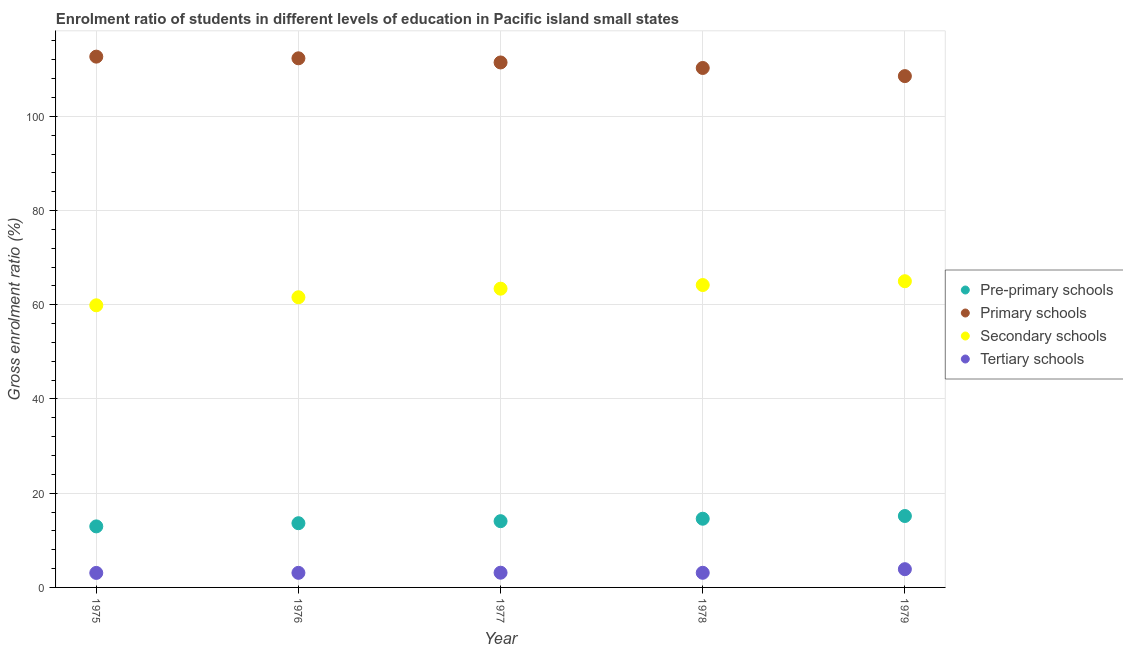How many different coloured dotlines are there?
Keep it short and to the point. 4. Is the number of dotlines equal to the number of legend labels?
Your response must be concise. Yes. What is the gross enrolment ratio in tertiary schools in 1976?
Give a very brief answer. 3.1. Across all years, what is the maximum gross enrolment ratio in primary schools?
Keep it short and to the point. 112.67. Across all years, what is the minimum gross enrolment ratio in tertiary schools?
Keep it short and to the point. 3.08. In which year was the gross enrolment ratio in tertiary schools maximum?
Make the answer very short. 1979. In which year was the gross enrolment ratio in pre-primary schools minimum?
Provide a short and direct response. 1975. What is the total gross enrolment ratio in pre-primary schools in the graph?
Offer a terse response. 70.39. What is the difference between the gross enrolment ratio in secondary schools in 1975 and that in 1977?
Give a very brief answer. -3.53. What is the difference between the gross enrolment ratio in primary schools in 1978 and the gross enrolment ratio in pre-primary schools in 1977?
Provide a short and direct response. 96.2. What is the average gross enrolment ratio in primary schools per year?
Your answer should be very brief. 111.04. In the year 1977, what is the difference between the gross enrolment ratio in primary schools and gross enrolment ratio in secondary schools?
Make the answer very short. 48.02. What is the ratio of the gross enrolment ratio in pre-primary schools in 1977 to that in 1978?
Offer a terse response. 0.96. Is the gross enrolment ratio in secondary schools in 1976 less than that in 1978?
Your response must be concise. Yes. What is the difference between the highest and the second highest gross enrolment ratio in primary schools?
Provide a succinct answer. 0.35. What is the difference between the highest and the lowest gross enrolment ratio in tertiary schools?
Provide a succinct answer. 0.79. Is the sum of the gross enrolment ratio in secondary schools in 1976 and 1979 greater than the maximum gross enrolment ratio in pre-primary schools across all years?
Provide a short and direct response. Yes. Is it the case that in every year, the sum of the gross enrolment ratio in primary schools and gross enrolment ratio in tertiary schools is greater than the sum of gross enrolment ratio in pre-primary schools and gross enrolment ratio in secondary schools?
Give a very brief answer. Yes. Is it the case that in every year, the sum of the gross enrolment ratio in pre-primary schools and gross enrolment ratio in primary schools is greater than the gross enrolment ratio in secondary schools?
Offer a very short reply. Yes. Does the gross enrolment ratio in secondary schools monotonically increase over the years?
Make the answer very short. Yes. Is the gross enrolment ratio in tertiary schools strictly greater than the gross enrolment ratio in primary schools over the years?
Ensure brevity in your answer.  No. Is the gross enrolment ratio in primary schools strictly less than the gross enrolment ratio in pre-primary schools over the years?
Make the answer very short. No. Does the graph contain any zero values?
Provide a short and direct response. No. Does the graph contain grids?
Offer a very short reply. Yes. How are the legend labels stacked?
Keep it short and to the point. Vertical. What is the title of the graph?
Your answer should be compact. Enrolment ratio of students in different levels of education in Pacific island small states. Does "Agricultural land" appear as one of the legend labels in the graph?
Provide a succinct answer. No. What is the label or title of the X-axis?
Your response must be concise. Year. What is the Gross enrolment ratio (%) of Pre-primary schools in 1975?
Keep it short and to the point. 12.96. What is the Gross enrolment ratio (%) of Primary schools in 1975?
Ensure brevity in your answer.  112.67. What is the Gross enrolment ratio (%) of Secondary schools in 1975?
Give a very brief answer. 59.89. What is the Gross enrolment ratio (%) in Tertiary schools in 1975?
Ensure brevity in your answer.  3.08. What is the Gross enrolment ratio (%) of Pre-primary schools in 1976?
Your answer should be very brief. 13.63. What is the Gross enrolment ratio (%) of Primary schools in 1976?
Your answer should be very brief. 112.32. What is the Gross enrolment ratio (%) of Secondary schools in 1976?
Ensure brevity in your answer.  61.59. What is the Gross enrolment ratio (%) in Tertiary schools in 1976?
Ensure brevity in your answer.  3.1. What is the Gross enrolment ratio (%) of Pre-primary schools in 1977?
Your answer should be compact. 14.06. What is the Gross enrolment ratio (%) of Primary schools in 1977?
Your answer should be compact. 111.43. What is the Gross enrolment ratio (%) in Secondary schools in 1977?
Make the answer very short. 63.42. What is the Gross enrolment ratio (%) in Tertiary schools in 1977?
Make the answer very short. 3.12. What is the Gross enrolment ratio (%) of Pre-primary schools in 1978?
Ensure brevity in your answer.  14.58. What is the Gross enrolment ratio (%) in Primary schools in 1978?
Offer a very short reply. 110.27. What is the Gross enrolment ratio (%) of Secondary schools in 1978?
Offer a terse response. 64.19. What is the Gross enrolment ratio (%) in Tertiary schools in 1978?
Offer a terse response. 3.11. What is the Gross enrolment ratio (%) of Pre-primary schools in 1979?
Offer a terse response. 15.16. What is the Gross enrolment ratio (%) of Primary schools in 1979?
Offer a terse response. 108.54. What is the Gross enrolment ratio (%) of Secondary schools in 1979?
Your answer should be very brief. 65. What is the Gross enrolment ratio (%) of Tertiary schools in 1979?
Keep it short and to the point. 3.87. Across all years, what is the maximum Gross enrolment ratio (%) in Pre-primary schools?
Keep it short and to the point. 15.16. Across all years, what is the maximum Gross enrolment ratio (%) in Primary schools?
Give a very brief answer. 112.67. Across all years, what is the maximum Gross enrolment ratio (%) in Secondary schools?
Make the answer very short. 65. Across all years, what is the maximum Gross enrolment ratio (%) in Tertiary schools?
Your response must be concise. 3.87. Across all years, what is the minimum Gross enrolment ratio (%) of Pre-primary schools?
Your response must be concise. 12.96. Across all years, what is the minimum Gross enrolment ratio (%) in Primary schools?
Ensure brevity in your answer.  108.54. Across all years, what is the minimum Gross enrolment ratio (%) of Secondary schools?
Provide a short and direct response. 59.89. Across all years, what is the minimum Gross enrolment ratio (%) of Tertiary schools?
Your response must be concise. 3.08. What is the total Gross enrolment ratio (%) in Pre-primary schools in the graph?
Provide a short and direct response. 70.39. What is the total Gross enrolment ratio (%) in Primary schools in the graph?
Ensure brevity in your answer.  555.22. What is the total Gross enrolment ratio (%) in Secondary schools in the graph?
Make the answer very short. 314.09. What is the total Gross enrolment ratio (%) in Tertiary schools in the graph?
Make the answer very short. 16.28. What is the difference between the Gross enrolment ratio (%) of Pre-primary schools in 1975 and that in 1976?
Keep it short and to the point. -0.68. What is the difference between the Gross enrolment ratio (%) in Primary schools in 1975 and that in 1976?
Keep it short and to the point. 0.35. What is the difference between the Gross enrolment ratio (%) in Secondary schools in 1975 and that in 1976?
Give a very brief answer. -1.71. What is the difference between the Gross enrolment ratio (%) in Tertiary schools in 1975 and that in 1976?
Provide a succinct answer. -0.01. What is the difference between the Gross enrolment ratio (%) in Pre-primary schools in 1975 and that in 1977?
Ensure brevity in your answer.  -1.11. What is the difference between the Gross enrolment ratio (%) in Primary schools in 1975 and that in 1977?
Offer a terse response. 1.24. What is the difference between the Gross enrolment ratio (%) in Secondary schools in 1975 and that in 1977?
Keep it short and to the point. -3.53. What is the difference between the Gross enrolment ratio (%) of Tertiary schools in 1975 and that in 1977?
Provide a succinct answer. -0.04. What is the difference between the Gross enrolment ratio (%) of Pre-primary schools in 1975 and that in 1978?
Offer a very short reply. -1.63. What is the difference between the Gross enrolment ratio (%) of Primary schools in 1975 and that in 1978?
Provide a short and direct response. 2.41. What is the difference between the Gross enrolment ratio (%) in Secondary schools in 1975 and that in 1978?
Provide a short and direct response. -4.3. What is the difference between the Gross enrolment ratio (%) of Tertiary schools in 1975 and that in 1978?
Your answer should be very brief. -0.03. What is the difference between the Gross enrolment ratio (%) in Pre-primary schools in 1975 and that in 1979?
Provide a short and direct response. -2.21. What is the difference between the Gross enrolment ratio (%) of Primary schools in 1975 and that in 1979?
Ensure brevity in your answer.  4.13. What is the difference between the Gross enrolment ratio (%) of Secondary schools in 1975 and that in 1979?
Keep it short and to the point. -5.11. What is the difference between the Gross enrolment ratio (%) of Tertiary schools in 1975 and that in 1979?
Ensure brevity in your answer.  -0.79. What is the difference between the Gross enrolment ratio (%) of Pre-primary schools in 1976 and that in 1977?
Offer a terse response. -0.43. What is the difference between the Gross enrolment ratio (%) in Primary schools in 1976 and that in 1977?
Make the answer very short. 0.88. What is the difference between the Gross enrolment ratio (%) in Secondary schools in 1976 and that in 1977?
Keep it short and to the point. -1.82. What is the difference between the Gross enrolment ratio (%) in Tertiary schools in 1976 and that in 1977?
Your answer should be compact. -0.03. What is the difference between the Gross enrolment ratio (%) of Pre-primary schools in 1976 and that in 1978?
Make the answer very short. -0.95. What is the difference between the Gross enrolment ratio (%) in Primary schools in 1976 and that in 1978?
Keep it short and to the point. 2.05. What is the difference between the Gross enrolment ratio (%) in Secondary schools in 1976 and that in 1978?
Keep it short and to the point. -2.6. What is the difference between the Gross enrolment ratio (%) in Tertiary schools in 1976 and that in 1978?
Make the answer very short. -0.01. What is the difference between the Gross enrolment ratio (%) of Pre-primary schools in 1976 and that in 1979?
Ensure brevity in your answer.  -1.53. What is the difference between the Gross enrolment ratio (%) in Primary schools in 1976 and that in 1979?
Offer a very short reply. 3.78. What is the difference between the Gross enrolment ratio (%) in Secondary schools in 1976 and that in 1979?
Offer a very short reply. -3.41. What is the difference between the Gross enrolment ratio (%) in Tertiary schools in 1976 and that in 1979?
Offer a terse response. -0.78. What is the difference between the Gross enrolment ratio (%) of Pre-primary schools in 1977 and that in 1978?
Your response must be concise. -0.52. What is the difference between the Gross enrolment ratio (%) in Primary schools in 1977 and that in 1978?
Your answer should be compact. 1.17. What is the difference between the Gross enrolment ratio (%) in Secondary schools in 1977 and that in 1978?
Give a very brief answer. -0.77. What is the difference between the Gross enrolment ratio (%) in Tertiary schools in 1977 and that in 1978?
Your response must be concise. 0.02. What is the difference between the Gross enrolment ratio (%) in Pre-primary schools in 1977 and that in 1979?
Provide a succinct answer. -1.1. What is the difference between the Gross enrolment ratio (%) of Primary schools in 1977 and that in 1979?
Your answer should be compact. 2.9. What is the difference between the Gross enrolment ratio (%) of Secondary schools in 1977 and that in 1979?
Offer a very short reply. -1.58. What is the difference between the Gross enrolment ratio (%) in Tertiary schools in 1977 and that in 1979?
Offer a very short reply. -0.75. What is the difference between the Gross enrolment ratio (%) of Pre-primary schools in 1978 and that in 1979?
Your answer should be very brief. -0.58. What is the difference between the Gross enrolment ratio (%) in Primary schools in 1978 and that in 1979?
Provide a short and direct response. 1.73. What is the difference between the Gross enrolment ratio (%) of Secondary schools in 1978 and that in 1979?
Keep it short and to the point. -0.81. What is the difference between the Gross enrolment ratio (%) in Tertiary schools in 1978 and that in 1979?
Make the answer very short. -0.76. What is the difference between the Gross enrolment ratio (%) of Pre-primary schools in 1975 and the Gross enrolment ratio (%) of Primary schools in 1976?
Make the answer very short. -99.36. What is the difference between the Gross enrolment ratio (%) of Pre-primary schools in 1975 and the Gross enrolment ratio (%) of Secondary schools in 1976?
Your response must be concise. -48.64. What is the difference between the Gross enrolment ratio (%) in Pre-primary schools in 1975 and the Gross enrolment ratio (%) in Tertiary schools in 1976?
Offer a terse response. 9.86. What is the difference between the Gross enrolment ratio (%) in Primary schools in 1975 and the Gross enrolment ratio (%) in Secondary schools in 1976?
Offer a very short reply. 51.08. What is the difference between the Gross enrolment ratio (%) in Primary schools in 1975 and the Gross enrolment ratio (%) in Tertiary schools in 1976?
Your response must be concise. 109.58. What is the difference between the Gross enrolment ratio (%) of Secondary schools in 1975 and the Gross enrolment ratio (%) of Tertiary schools in 1976?
Your answer should be very brief. 56.79. What is the difference between the Gross enrolment ratio (%) of Pre-primary schools in 1975 and the Gross enrolment ratio (%) of Primary schools in 1977?
Your answer should be compact. -98.48. What is the difference between the Gross enrolment ratio (%) in Pre-primary schools in 1975 and the Gross enrolment ratio (%) in Secondary schools in 1977?
Give a very brief answer. -50.46. What is the difference between the Gross enrolment ratio (%) of Pre-primary schools in 1975 and the Gross enrolment ratio (%) of Tertiary schools in 1977?
Your answer should be very brief. 9.83. What is the difference between the Gross enrolment ratio (%) in Primary schools in 1975 and the Gross enrolment ratio (%) in Secondary schools in 1977?
Your response must be concise. 49.26. What is the difference between the Gross enrolment ratio (%) in Primary schools in 1975 and the Gross enrolment ratio (%) in Tertiary schools in 1977?
Make the answer very short. 109.55. What is the difference between the Gross enrolment ratio (%) in Secondary schools in 1975 and the Gross enrolment ratio (%) in Tertiary schools in 1977?
Provide a succinct answer. 56.76. What is the difference between the Gross enrolment ratio (%) of Pre-primary schools in 1975 and the Gross enrolment ratio (%) of Primary schools in 1978?
Make the answer very short. -97.31. What is the difference between the Gross enrolment ratio (%) of Pre-primary schools in 1975 and the Gross enrolment ratio (%) of Secondary schools in 1978?
Offer a very short reply. -51.23. What is the difference between the Gross enrolment ratio (%) in Pre-primary schools in 1975 and the Gross enrolment ratio (%) in Tertiary schools in 1978?
Provide a succinct answer. 9.85. What is the difference between the Gross enrolment ratio (%) of Primary schools in 1975 and the Gross enrolment ratio (%) of Secondary schools in 1978?
Offer a terse response. 48.48. What is the difference between the Gross enrolment ratio (%) in Primary schools in 1975 and the Gross enrolment ratio (%) in Tertiary schools in 1978?
Make the answer very short. 109.56. What is the difference between the Gross enrolment ratio (%) of Secondary schools in 1975 and the Gross enrolment ratio (%) of Tertiary schools in 1978?
Keep it short and to the point. 56.78. What is the difference between the Gross enrolment ratio (%) in Pre-primary schools in 1975 and the Gross enrolment ratio (%) in Primary schools in 1979?
Provide a short and direct response. -95.58. What is the difference between the Gross enrolment ratio (%) of Pre-primary schools in 1975 and the Gross enrolment ratio (%) of Secondary schools in 1979?
Make the answer very short. -52.04. What is the difference between the Gross enrolment ratio (%) in Pre-primary schools in 1975 and the Gross enrolment ratio (%) in Tertiary schools in 1979?
Offer a very short reply. 9.08. What is the difference between the Gross enrolment ratio (%) in Primary schools in 1975 and the Gross enrolment ratio (%) in Secondary schools in 1979?
Keep it short and to the point. 47.67. What is the difference between the Gross enrolment ratio (%) in Primary schools in 1975 and the Gross enrolment ratio (%) in Tertiary schools in 1979?
Your answer should be very brief. 108.8. What is the difference between the Gross enrolment ratio (%) of Secondary schools in 1975 and the Gross enrolment ratio (%) of Tertiary schools in 1979?
Keep it short and to the point. 56.02. What is the difference between the Gross enrolment ratio (%) in Pre-primary schools in 1976 and the Gross enrolment ratio (%) in Primary schools in 1977?
Provide a succinct answer. -97.8. What is the difference between the Gross enrolment ratio (%) of Pre-primary schools in 1976 and the Gross enrolment ratio (%) of Secondary schools in 1977?
Ensure brevity in your answer.  -49.78. What is the difference between the Gross enrolment ratio (%) in Pre-primary schools in 1976 and the Gross enrolment ratio (%) in Tertiary schools in 1977?
Your response must be concise. 10.51. What is the difference between the Gross enrolment ratio (%) of Primary schools in 1976 and the Gross enrolment ratio (%) of Secondary schools in 1977?
Give a very brief answer. 48.9. What is the difference between the Gross enrolment ratio (%) in Primary schools in 1976 and the Gross enrolment ratio (%) in Tertiary schools in 1977?
Offer a terse response. 109.19. What is the difference between the Gross enrolment ratio (%) of Secondary schools in 1976 and the Gross enrolment ratio (%) of Tertiary schools in 1977?
Make the answer very short. 58.47. What is the difference between the Gross enrolment ratio (%) in Pre-primary schools in 1976 and the Gross enrolment ratio (%) in Primary schools in 1978?
Offer a very short reply. -96.63. What is the difference between the Gross enrolment ratio (%) in Pre-primary schools in 1976 and the Gross enrolment ratio (%) in Secondary schools in 1978?
Provide a succinct answer. -50.56. What is the difference between the Gross enrolment ratio (%) of Pre-primary schools in 1976 and the Gross enrolment ratio (%) of Tertiary schools in 1978?
Your answer should be compact. 10.52. What is the difference between the Gross enrolment ratio (%) of Primary schools in 1976 and the Gross enrolment ratio (%) of Secondary schools in 1978?
Give a very brief answer. 48.13. What is the difference between the Gross enrolment ratio (%) of Primary schools in 1976 and the Gross enrolment ratio (%) of Tertiary schools in 1978?
Give a very brief answer. 109.21. What is the difference between the Gross enrolment ratio (%) in Secondary schools in 1976 and the Gross enrolment ratio (%) in Tertiary schools in 1978?
Provide a short and direct response. 58.49. What is the difference between the Gross enrolment ratio (%) in Pre-primary schools in 1976 and the Gross enrolment ratio (%) in Primary schools in 1979?
Your answer should be compact. -94.91. What is the difference between the Gross enrolment ratio (%) in Pre-primary schools in 1976 and the Gross enrolment ratio (%) in Secondary schools in 1979?
Offer a very short reply. -51.37. What is the difference between the Gross enrolment ratio (%) of Pre-primary schools in 1976 and the Gross enrolment ratio (%) of Tertiary schools in 1979?
Provide a succinct answer. 9.76. What is the difference between the Gross enrolment ratio (%) of Primary schools in 1976 and the Gross enrolment ratio (%) of Secondary schools in 1979?
Provide a short and direct response. 47.32. What is the difference between the Gross enrolment ratio (%) in Primary schools in 1976 and the Gross enrolment ratio (%) in Tertiary schools in 1979?
Your response must be concise. 108.44. What is the difference between the Gross enrolment ratio (%) in Secondary schools in 1976 and the Gross enrolment ratio (%) in Tertiary schools in 1979?
Give a very brief answer. 57.72. What is the difference between the Gross enrolment ratio (%) in Pre-primary schools in 1977 and the Gross enrolment ratio (%) in Primary schools in 1978?
Give a very brief answer. -96.2. What is the difference between the Gross enrolment ratio (%) in Pre-primary schools in 1977 and the Gross enrolment ratio (%) in Secondary schools in 1978?
Ensure brevity in your answer.  -50.13. What is the difference between the Gross enrolment ratio (%) in Pre-primary schools in 1977 and the Gross enrolment ratio (%) in Tertiary schools in 1978?
Give a very brief answer. 10.96. What is the difference between the Gross enrolment ratio (%) in Primary schools in 1977 and the Gross enrolment ratio (%) in Secondary schools in 1978?
Give a very brief answer. 47.25. What is the difference between the Gross enrolment ratio (%) of Primary schools in 1977 and the Gross enrolment ratio (%) of Tertiary schools in 1978?
Offer a very short reply. 108.33. What is the difference between the Gross enrolment ratio (%) of Secondary schools in 1977 and the Gross enrolment ratio (%) of Tertiary schools in 1978?
Your response must be concise. 60.31. What is the difference between the Gross enrolment ratio (%) of Pre-primary schools in 1977 and the Gross enrolment ratio (%) of Primary schools in 1979?
Offer a very short reply. -94.47. What is the difference between the Gross enrolment ratio (%) of Pre-primary schools in 1977 and the Gross enrolment ratio (%) of Secondary schools in 1979?
Ensure brevity in your answer.  -50.94. What is the difference between the Gross enrolment ratio (%) of Pre-primary schools in 1977 and the Gross enrolment ratio (%) of Tertiary schools in 1979?
Ensure brevity in your answer.  10.19. What is the difference between the Gross enrolment ratio (%) in Primary schools in 1977 and the Gross enrolment ratio (%) in Secondary schools in 1979?
Provide a succinct answer. 46.44. What is the difference between the Gross enrolment ratio (%) in Primary schools in 1977 and the Gross enrolment ratio (%) in Tertiary schools in 1979?
Offer a very short reply. 107.56. What is the difference between the Gross enrolment ratio (%) in Secondary schools in 1977 and the Gross enrolment ratio (%) in Tertiary schools in 1979?
Your answer should be very brief. 59.54. What is the difference between the Gross enrolment ratio (%) of Pre-primary schools in 1978 and the Gross enrolment ratio (%) of Primary schools in 1979?
Provide a succinct answer. -93.95. What is the difference between the Gross enrolment ratio (%) of Pre-primary schools in 1978 and the Gross enrolment ratio (%) of Secondary schools in 1979?
Give a very brief answer. -50.42. What is the difference between the Gross enrolment ratio (%) of Pre-primary schools in 1978 and the Gross enrolment ratio (%) of Tertiary schools in 1979?
Ensure brevity in your answer.  10.71. What is the difference between the Gross enrolment ratio (%) of Primary schools in 1978 and the Gross enrolment ratio (%) of Secondary schools in 1979?
Keep it short and to the point. 45.27. What is the difference between the Gross enrolment ratio (%) in Primary schools in 1978 and the Gross enrolment ratio (%) in Tertiary schools in 1979?
Provide a short and direct response. 106.39. What is the difference between the Gross enrolment ratio (%) of Secondary schools in 1978 and the Gross enrolment ratio (%) of Tertiary schools in 1979?
Ensure brevity in your answer.  60.32. What is the average Gross enrolment ratio (%) in Pre-primary schools per year?
Ensure brevity in your answer.  14.08. What is the average Gross enrolment ratio (%) in Primary schools per year?
Your answer should be compact. 111.04. What is the average Gross enrolment ratio (%) in Secondary schools per year?
Provide a short and direct response. 62.82. What is the average Gross enrolment ratio (%) of Tertiary schools per year?
Provide a short and direct response. 3.26. In the year 1975, what is the difference between the Gross enrolment ratio (%) in Pre-primary schools and Gross enrolment ratio (%) in Primary schools?
Make the answer very short. -99.72. In the year 1975, what is the difference between the Gross enrolment ratio (%) in Pre-primary schools and Gross enrolment ratio (%) in Secondary schools?
Your answer should be very brief. -46.93. In the year 1975, what is the difference between the Gross enrolment ratio (%) in Pre-primary schools and Gross enrolment ratio (%) in Tertiary schools?
Provide a succinct answer. 9.87. In the year 1975, what is the difference between the Gross enrolment ratio (%) of Primary schools and Gross enrolment ratio (%) of Secondary schools?
Keep it short and to the point. 52.78. In the year 1975, what is the difference between the Gross enrolment ratio (%) of Primary schools and Gross enrolment ratio (%) of Tertiary schools?
Your answer should be very brief. 109.59. In the year 1975, what is the difference between the Gross enrolment ratio (%) of Secondary schools and Gross enrolment ratio (%) of Tertiary schools?
Keep it short and to the point. 56.81. In the year 1976, what is the difference between the Gross enrolment ratio (%) of Pre-primary schools and Gross enrolment ratio (%) of Primary schools?
Offer a very short reply. -98.69. In the year 1976, what is the difference between the Gross enrolment ratio (%) of Pre-primary schools and Gross enrolment ratio (%) of Secondary schools?
Ensure brevity in your answer.  -47.96. In the year 1976, what is the difference between the Gross enrolment ratio (%) of Pre-primary schools and Gross enrolment ratio (%) of Tertiary schools?
Offer a terse response. 10.54. In the year 1976, what is the difference between the Gross enrolment ratio (%) of Primary schools and Gross enrolment ratio (%) of Secondary schools?
Make the answer very short. 50.72. In the year 1976, what is the difference between the Gross enrolment ratio (%) of Primary schools and Gross enrolment ratio (%) of Tertiary schools?
Provide a short and direct response. 109.22. In the year 1976, what is the difference between the Gross enrolment ratio (%) of Secondary schools and Gross enrolment ratio (%) of Tertiary schools?
Offer a very short reply. 58.5. In the year 1977, what is the difference between the Gross enrolment ratio (%) of Pre-primary schools and Gross enrolment ratio (%) of Primary schools?
Your answer should be very brief. -97.37. In the year 1977, what is the difference between the Gross enrolment ratio (%) in Pre-primary schools and Gross enrolment ratio (%) in Secondary schools?
Your answer should be compact. -49.35. In the year 1977, what is the difference between the Gross enrolment ratio (%) of Pre-primary schools and Gross enrolment ratio (%) of Tertiary schools?
Keep it short and to the point. 10.94. In the year 1977, what is the difference between the Gross enrolment ratio (%) of Primary schools and Gross enrolment ratio (%) of Secondary schools?
Keep it short and to the point. 48.02. In the year 1977, what is the difference between the Gross enrolment ratio (%) in Primary schools and Gross enrolment ratio (%) in Tertiary schools?
Provide a short and direct response. 108.31. In the year 1977, what is the difference between the Gross enrolment ratio (%) in Secondary schools and Gross enrolment ratio (%) in Tertiary schools?
Make the answer very short. 60.29. In the year 1978, what is the difference between the Gross enrolment ratio (%) of Pre-primary schools and Gross enrolment ratio (%) of Primary schools?
Provide a succinct answer. -95.68. In the year 1978, what is the difference between the Gross enrolment ratio (%) in Pre-primary schools and Gross enrolment ratio (%) in Secondary schools?
Your response must be concise. -49.61. In the year 1978, what is the difference between the Gross enrolment ratio (%) in Pre-primary schools and Gross enrolment ratio (%) in Tertiary schools?
Offer a very short reply. 11.48. In the year 1978, what is the difference between the Gross enrolment ratio (%) of Primary schools and Gross enrolment ratio (%) of Secondary schools?
Provide a short and direct response. 46.08. In the year 1978, what is the difference between the Gross enrolment ratio (%) of Primary schools and Gross enrolment ratio (%) of Tertiary schools?
Provide a succinct answer. 107.16. In the year 1978, what is the difference between the Gross enrolment ratio (%) of Secondary schools and Gross enrolment ratio (%) of Tertiary schools?
Provide a short and direct response. 61.08. In the year 1979, what is the difference between the Gross enrolment ratio (%) of Pre-primary schools and Gross enrolment ratio (%) of Primary schools?
Your answer should be compact. -93.38. In the year 1979, what is the difference between the Gross enrolment ratio (%) of Pre-primary schools and Gross enrolment ratio (%) of Secondary schools?
Make the answer very short. -49.84. In the year 1979, what is the difference between the Gross enrolment ratio (%) in Pre-primary schools and Gross enrolment ratio (%) in Tertiary schools?
Your answer should be compact. 11.29. In the year 1979, what is the difference between the Gross enrolment ratio (%) of Primary schools and Gross enrolment ratio (%) of Secondary schools?
Your response must be concise. 43.54. In the year 1979, what is the difference between the Gross enrolment ratio (%) in Primary schools and Gross enrolment ratio (%) in Tertiary schools?
Keep it short and to the point. 104.67. In the year 1979, what is the difference between the Gross enrolment ratio (%) of Secondary schools and Gross enrolment ratio (%) of Tertiary schools?
Your answer should be very brief. 61.13. What is the ratio of the Gross enrolment ratio (%) in Pre-primary schools in 1975 to that in 1976?
Your answer should be very brief. 0.95. What is the ratio of the Gross enrolment ratio (%) in Secondary schools in 1975 to that in 1976?
Your response must be concise. 0.97. What is the ratio of the Gross enrolment ratio (%) in Tertiary schools in 1975 to that in 1976?
Give a very brief answer. 1. What is the ratio of the Gross enrolment ratio (%) in Pre-primary schools in 1975 to that in 1977?
Make the answer very short. 0.92. What is the ratio of the Gross enrolment ratio (%) in Primary schools in 1975 to that in 1977?
Give a very brief answer. 1.01. What is the ratio of the Gross enrolment ratio (%) in Tertiary schools in 1975 to that in 1977?
Keep it short and to the point. 0.99. What is the ratio of the Gross enrolment ratio (%) of Pre-primary schools in 1975 to that in 1978?
Make the answer very short. 0.89. What is the ratio of the Gross enrolment ratio (%) in Primary schools in 1975 to that in 1978?
Provide a short and direct response. 1.02. What is the ratio of the Gross enrolment ratio (%) in Secondary schools in 1975 to that in 1978?
Provide a succinct answer. 0.93. What is the ratio of the Gross enrolment ratio (%) of Tertiary schools in 1975 to that in 1978?
Offer a terse response. 0.99. What is the ratio of the Gross enrolment ratio (%) of Pre-primary schools in 1975 to that in 1979?
Offer a terse response. 0.85. What is the ratio of the Gross enrolment ratio (%) of Primary schools in 1975 to that in 1979?
Offer a terse response. 1.04. What is the ratio of the Gross enrolment ratio (%) in Secondary schools in 1975 to that in 1979?
Your answer should be very brief. 0.92. What is the ratio of the Gross enrolment ratio (%) of Tertiary schools in 1975 to that in 1979?
Your response must be concise. 0.8. What is the ratio of the Gross enrolment ratio (%) of Pre-primary schools in 1976 to that in 1977?
Offer a terse response. 0.97. What is the ratio of the Gross enrolment ratio (%) in Primary schools in 1976 to that in 1977?
Provide a short and direct response. 1.01. What is the ratio of the Gross enrolment ratio (%) in Secondary schools in 1976 to that in 1977?
Offer a terse response. 0.97. What is the ratio of the Gross enrolment ratio (%) of Tertiary schools in 1976 to that in 1977?
Ensure brevity in your answer.  0.99. What is the ratio of the Gross enrolment ratio (%) in Pre-primary schools in 1976 to that in 1978?
Provide a short and direct response. 0.93. What is the ratio of the Gross enrolment ratio (%) in Primary schools in 1976 to that in 1978?
Your answer should be compact. 1.02. What is the ratio of the Gross enrolment ratio (%) in Secondary schools in 1976 to that in 1978?
Give a very brief answer. 0.96. What is the ratio of the Gross enrolment ratio (%) of Pre-primary schools in 1976 to that in 1979?
Offer a very short reply. 0.9. What is the ratio of the Gross enrolment ratio (%) of Primary schools in 1976 to that in 1979?
Offer a very short reply. 1.03. What is the ratio of the Gross enrolment ratio (%) of Secondary schools in 1976 to that in 1979?
Provide a short and direct response. 0.95. What is the ratio of the Gross enrolment ratio (%) of Tertiary schools in 1976 to that in 1979?
Give a very brief answer. 0.8. What is the ratio of the Gross enrolment ratio (%) in Primary schools in 1977 to that in 1978?
Make the answer very short. 1.01. What is the ratio of the Gross enrolment ratio (%) in Secondary schools in 1977 to that in 1978?
Ensure brevity in your answer.  0.99. What is the ratio of the Gross enrolment ratio (%) of Tertiary schools in 1977 to that in 1978?
Give a very brief answer. 1.01. What is the ratio of the Gross enrolment ratio (%) of Pre-primary schools in 1977 to that in 1979?
Your answer should be very brief. 0.93. What is the ratio of the Gross enrolment ratio (%) in Primary schools in 1977 to that in 1979?
Your response must be concise. 1.03. What is the ratio of the Gross enrolment ratio (%) in Secondary schools in 1977 to that in 1979?
Give a very brief answer. 0.98. What is the ratio of the Gross enrolment ratio (%) of Tertiary schools in 1977 to that in 1979?
Your response must be concise. 0.81. What is the ratio of the Gross enrolment ratio (%) of Pre-primary schools in 1978 to that in 1979?
Make the answer very short. 0.96. What is the ratio of the Gross enrolment ratio (%) of Primary schools in 1978 to that in 1979?
Offer a very short reply. 1.02. What is the ratio of the Gross enrolment ratio (%) in Secondary schools in 1978 to that in 1979?
Offer a terse response. 0.99. What is the ratio of the Gross enrolment ratio (%) in Tertiary schools in 1978 to that in 1979?
Ensure brevity in your answer.  0.8. What is the difference between the highest and the second highest Gross enrolment ratio (%) in Pre-primary schools?
Your answer should be very brief. 0.58. What is the difference between the highest and the second highest Gross enrolment ratio (%) of Primary schools?
Ensure brevity in your answer.  0.35. What is the difference between the highest and the second highest Gross enrolment ratio (%) in Secondary schools?
Give a very brief answer. 0.81. What is the difference between the highest and the second highest Gross enrolment ratio (%) of Tertiary schools?
Provide a short and direct response. 0.75. What is the difference between the highest and the lowest Gross enrolment ratio (%) in Pre-primary schools?
Your response must be concise. 2.21. What is the difference between the highest and the lowest Gross enrolment ratio (%) of Primary schools?
Keep it short and to the point. 4.13. What is the difference between the highest and the lowest Gross enrolment ratio (%) in Secondary schools?
Offer a terse response. 5.11. What is the difference between the highest and the lowest Gross enrolment ratio (%) in Tertiary schools?
Keep it short and to the point. 0.79. 